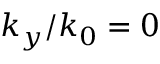Convert formula to latex. <formula><loc_0><loc_0><loc_500><loc_500>k _ { y } / k _ { 0 } = 0</formula> 